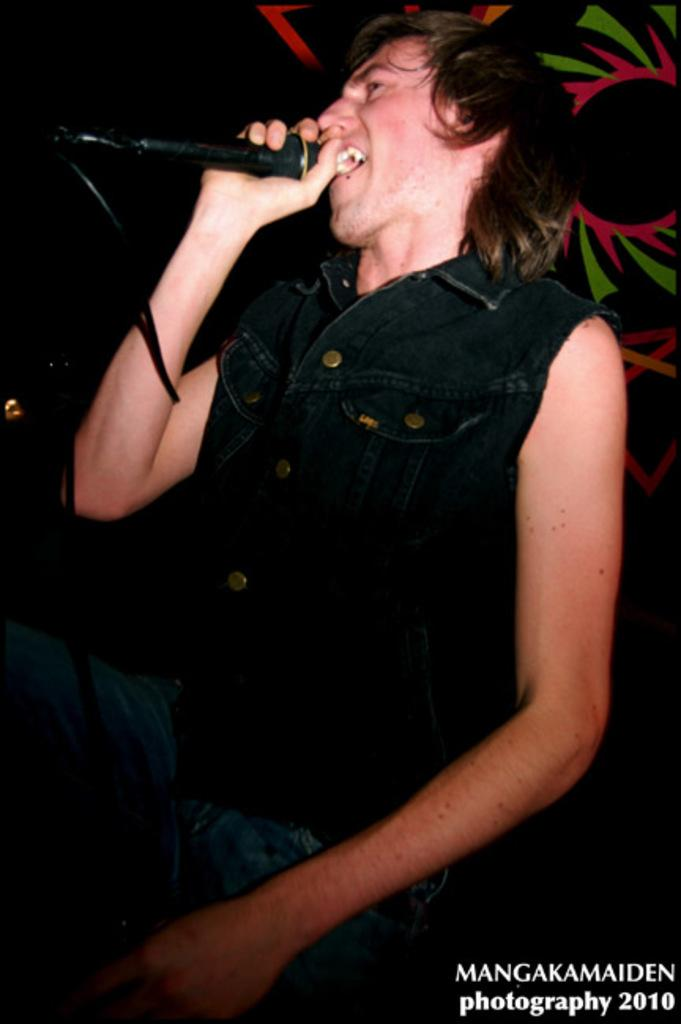Who is the main subject in the image? There is a man in the image. What is the man doing in the image? The man is singing. What object is the man holding in the image? The man is holding a microphone. Can you describe the background of the image? There is a design in the background of the image. What type of blade is being used by the man in the image? There is no blade present in the image; the man is holding a microphone while singing. 